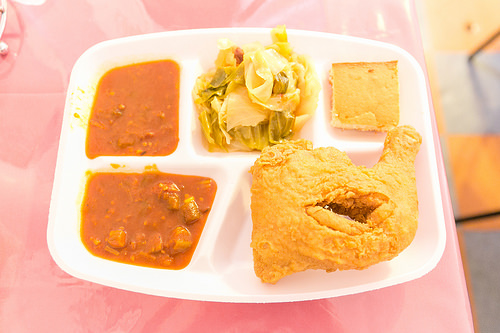<image>
Is the chicken in front of the bread? Yes. The chicken is positioned in front of the bread, appearing closer to the camera viewpoint. 